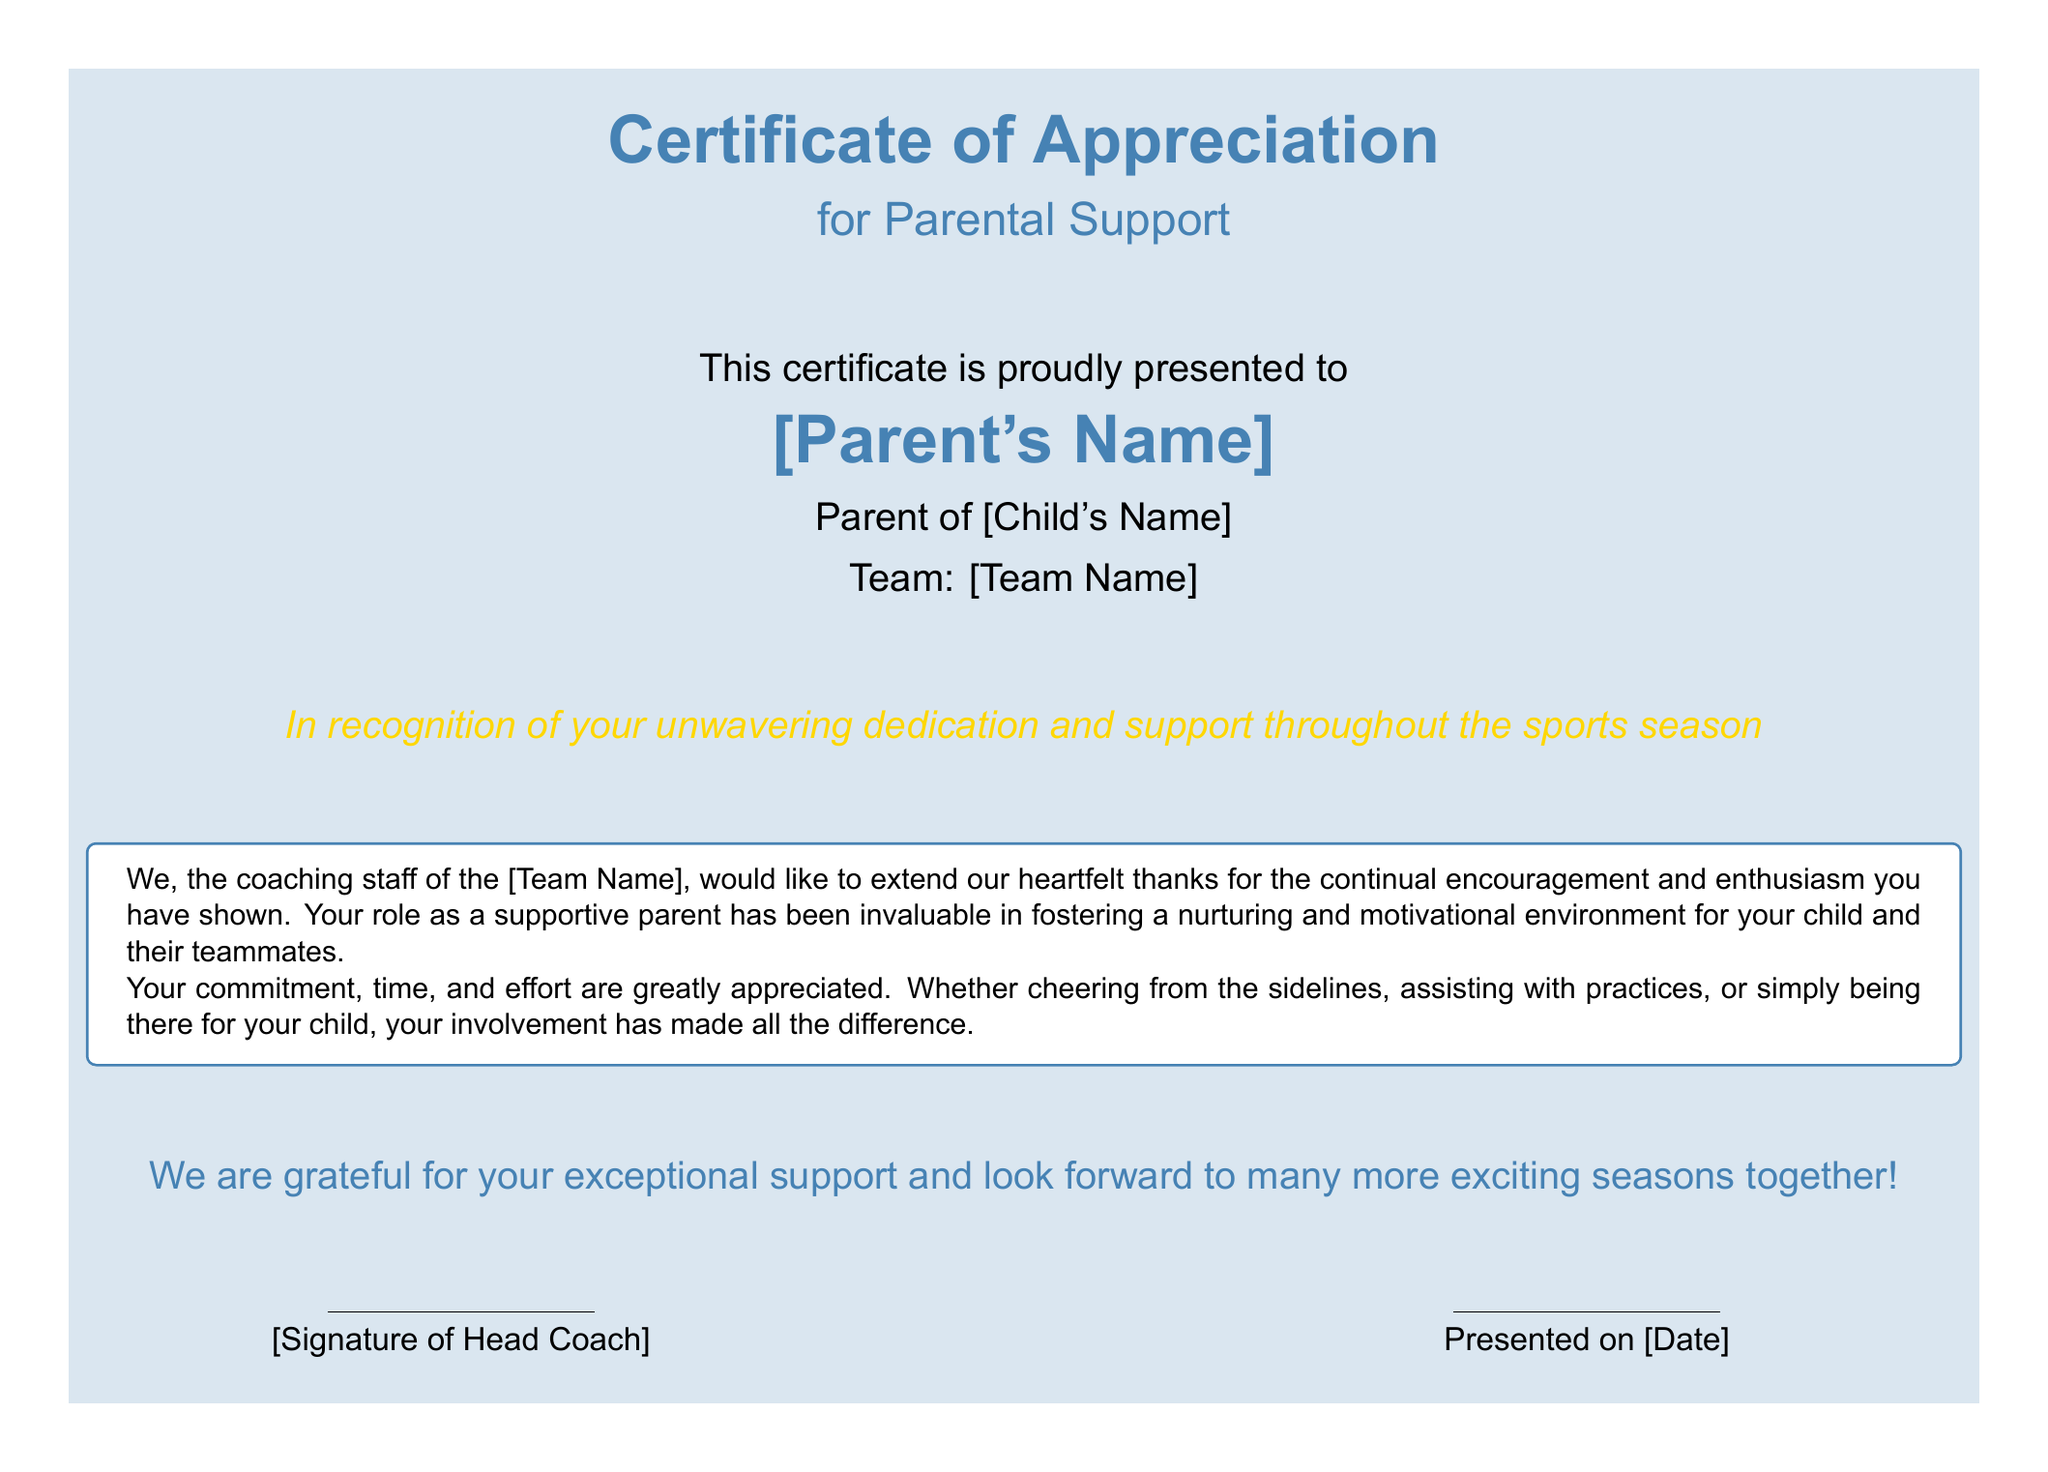What is the title of the certificate? The title of the certificate is presented at the top, indicating its purpose.
Answer: Certificate of Appreciation What is the specific commendation mentioned in the certificate? The certificate specifically honors parental commitment during the sports season.
Answer: for Parental Support Who is the certificate presented to? The certificate displays the name of the parent receiving the recognition.
Answer: [Parent's Name] What is the name of the child mentioned in the certificate? The certificate highlights the parenthood of the individual being recognized.
Answer: [Child's Name] What does the certificate acknowledge about the parent? The certificate elaborates on the parent's involvement throughout the sports season.
Answer: unwavering dedication and support What is the name of the team associated with the certificate? The certificate notes the team's name to identify the sports group involved.
Answer: [Team Name] Who signs the certificate? The document specifies the position of the individual who endorses the certificate.
Answer: Head Coach When is the certificate presented? The certificate includes a designated date for when it is issued.
Answer: [Date] What type of message is included in the box? The box contains a message of gratitude from the coaching staff to the parent.
Answer: heartfelt thanks 